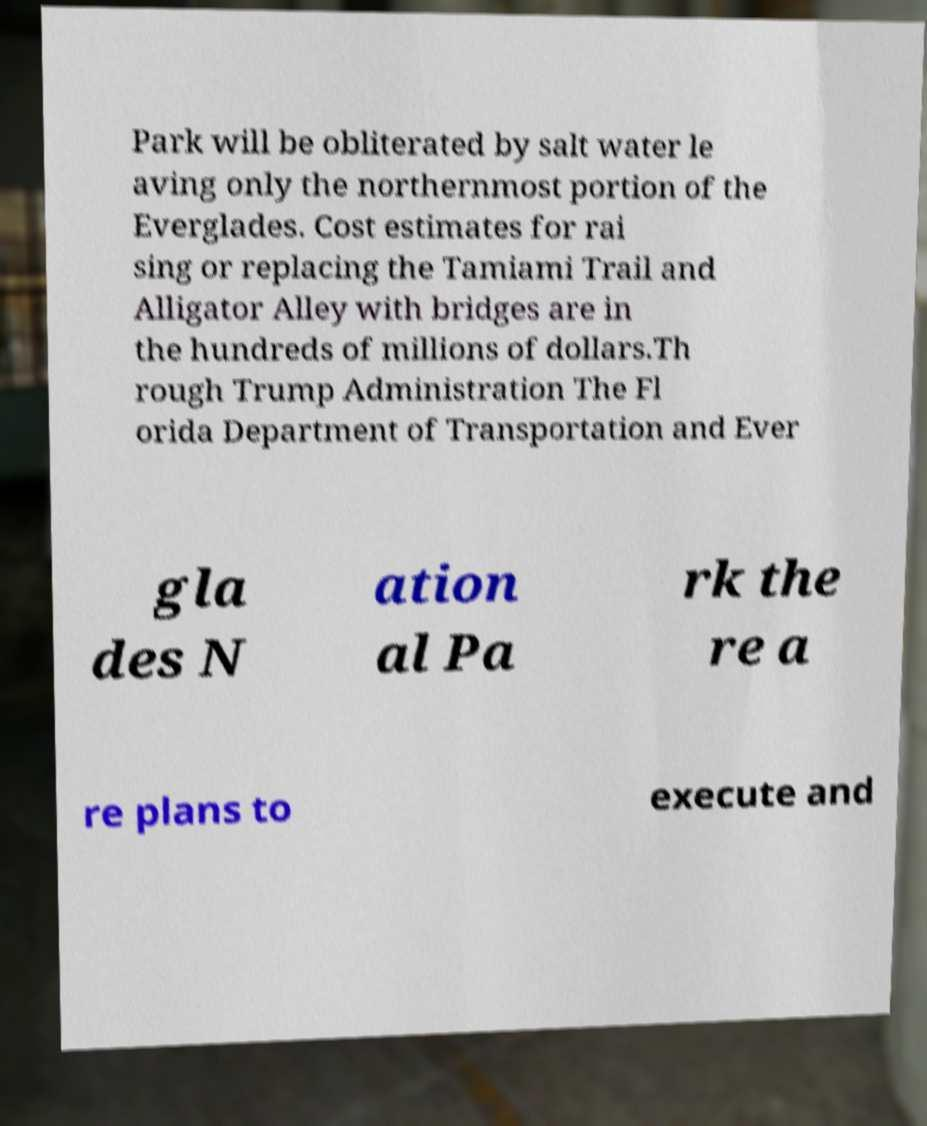Could you extract and type out the text from this image? Park will be obliterated by salt water le aving only the northernmost portion of the Everglades. Cost estimates for rai sing or replacing the Tamiami Trail and Alligator Alley with bridges are in the hundreds of millions of dollars.Th rough Trump Administration The Fl orida Department of Transportation and Ever gla des N ation al Pa rk the re a re plans to execute and 